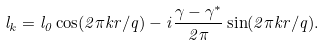<formula> <loc_0><loc_0><loc_500><loc_500>l _ { k } = l _ { 0 } \cos ( 2 \pi k r / q ) - i \frac { \gamma - \gamma ^ { * } } { 2 \pi } \sin ( 2 \pi k r / q ) .</formula> 